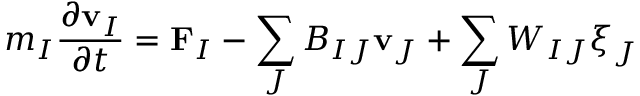<formula> <loc_0><loc_0><loc_500><loc_500>m _ { I } \frac { \partial v _ { I } } { \partial t } = F _ { I } - \sum _ { J } B _ { I J } v _ { J } + \sum _ { J } W _ { I J } \boldsymbol \xi _ { J }</formula> 